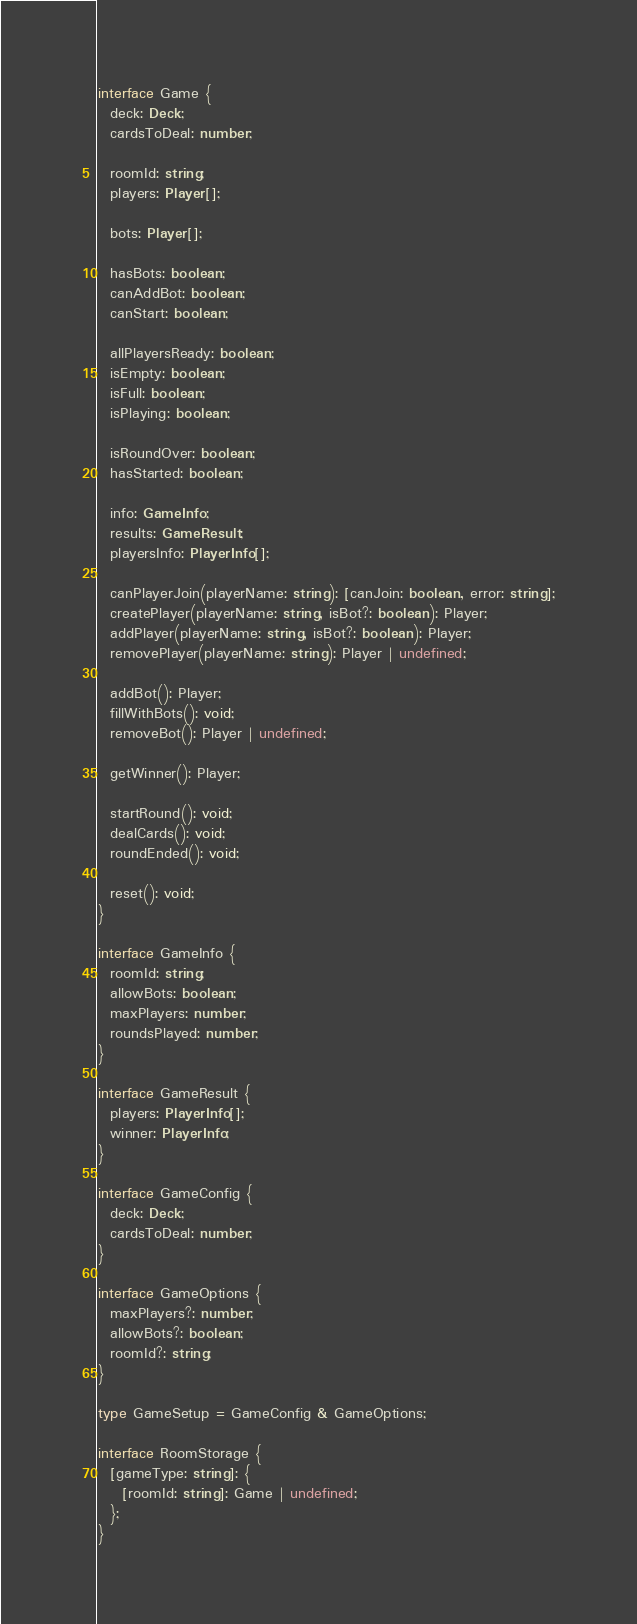<code> <loc_0><loc_0><loc_500><loc_500><_TypeScript_>interface Game {
  deck: Deck;
  cardsToDeal: number;

  roomId: string;
  players: Player[];

  bots: Player[];

  hasBots: boolean;
  canAddBot: boolean;
  canStart: boolean;

  allPlayersReady: boolean;
  isEmpty: boolean;
  isFull: boolean;
  isPlaying: boolean;

  isRoundOver: boolean;
  hasStarted: boolean;

  info: GameInfo;
  results: GameResult;
  playersInfo: PlayerInfo[];
  
  canPlayerJoin(playerName: string): [canJoin: boolean, error: string];
  createPlayer(playerName: string, isBot?: boolean): Player;
  addPlayer(playerName: string, isBot?: boolean): Player;
  removePlayer(playerName: string): Player | undefined;

  addBot(): Player;
  fillWithBots(): void;
  removeBot(): Player | undefined;

  getWinner(): Player;

  startRound(): void;
  dealCards(): void;
  roundEnded(): void;

  reset(): void;
}

interface GameInfo {
  roomId: string;
  allowBots: boolean;
  maxPlayers: number;
  roundsPlayed: number;
}

interface GameResult {
  players: PlayerInfo[];
  winner: PlayerInfo;
}

interface GameConfig {
  deck: Deck;
  cardsToDeal: number;
}

interface GameOptions {
  maxPlayers?: number;
  allowBots?: boolean;
  roomId?: string;
}

type GameSetup = GameConfig & GameOptions;

interface RoomStorage {
  [gameType: string]: {
    [roomId: string]: Game | undefined;
  };
}
</code> 